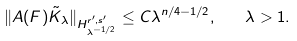Convert formula to latex. <formula><loc_0><loc_0><loc_500><loc_500>\| A ( F ) \tilde { K } _ { \lambda } \| _ { H ^ { r ^ { \prime } , s ^ { \prime } } _ { \lambda ^ { - 1 / 2 } } } \leq C \lambda ^ { n / 4 - 1 / 2 } , \quad \lambda > 1 .</formula> 